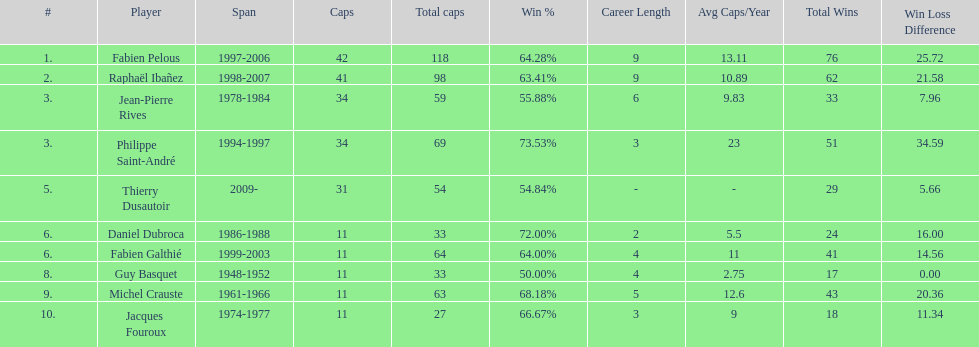Which competitor holds the highest victory rate? Philippe Saint-André. 